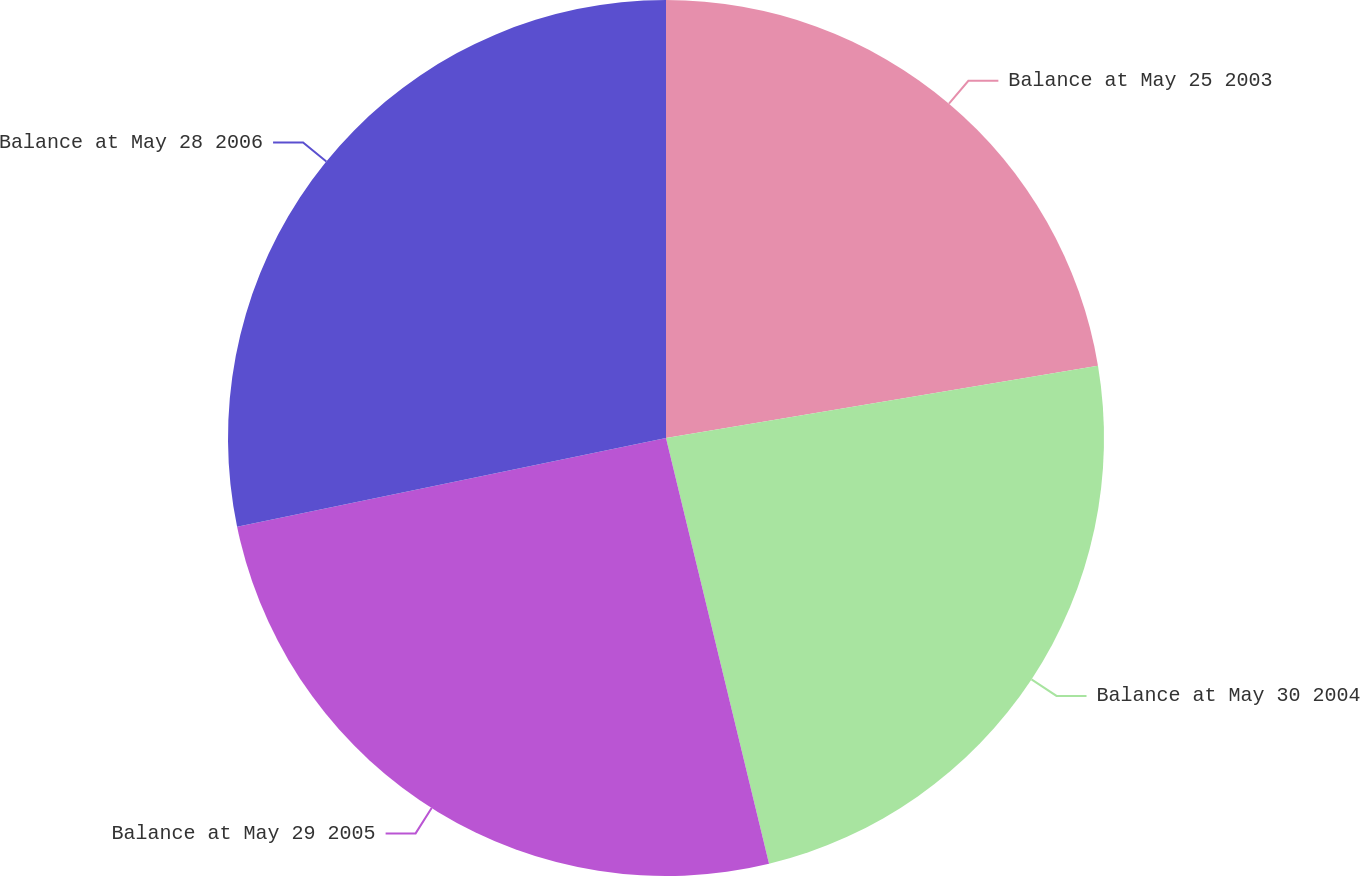Convert chart. <chart><loc_0><loc_0><loc_500><loc_500><pie_chart><fcel>Balance at May 25 2003<fcel>Balance at May 30 2004<fcel>Balance at May 29 2005<fcel>Balance at May 28 2006<nl><fcel>22.36%<fcel>23.86%<fcel>25.53%<fcel>28.25%<nl></chart> 